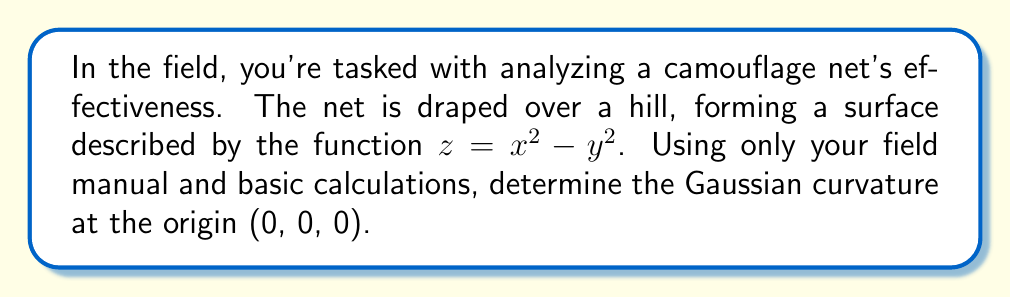Can you answer this question? Let's approach this step-by-step using basic differential geometry:

1) The Gaussian curvature K is given by $K = \frac{LN - M^2}{EG - F^2}$, where L, M, N are coefficients of the second fundamental form, and E, F, G are coefficients of the first fundamental form.

2) For a surface $z = f(x,y)$, we have:
   $E = 1 + (\frac{\partial f}{\partial x})^2$
   $F = \frac{\partial f}{\partial x}\frac{\partial f}{\partial y}$
   $G = 1 + (\frac{\partial f}{\partial y})^2$

3) Calculate partial derivatives:
   $\frac{\partial f}{\partial x} = 2x$
   $\frac{\partial f}{\partial y} = -2y$

4) At (0, 0, 0):
   $E = 1 + (2x)^2 = 1$
   $F = (2x)(-2y) = 0$
   $G = 1 + (-2y)^2 = 1$

5) For L, M, N:
   $L = \frac{\partial^2 f}{\partial x^2} = 2$
   $M = \frac{\partial^2 f}{\partial x\partial y} = 0$
   $N = \frac{\partial^2 f}{\partial y^2} = -2$

6) Now, calculate K:
   $K = \frac{LN - M^2}{EG - F^2} = \frac{(2)(-2) - 0^2}{(1)(1) - 0^2} = -4$

Therefore, the Gaussian curvature at the origin is -4.
Answer: $-4$ 